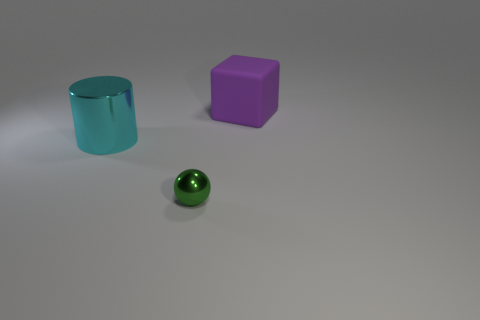What number of big things are both on the right side of the tiny metallic object and on the left side of the big cube?
Ensure brevity in your answer.  0. There is a object in front of the cyan cylinder; what is its material?
Give a very brief answer. Metal. The cylinder that is the same material as the tiny thing is what size?
Keep it short and to the point. Large. Is the size of the object behind the big cyan metallic object the same as the metal thing that is right of the large cyan object?
Your answer should be compact. No. What material is the cube that is the same size as the cyan cylinder?
Ensure brevity in your answer.  Rubber. There is a object that is in front of the purple cube and to the right of the large metal cylinder; what material is it made of?
Offer a terse response. Metal. Are any purple rubber objects visible?
Your answer should be very brief. Yes. Does the metallic cylinder have the same color as the tiny metallic sphere that is in front of the big cyan metallic cylinder?
Offer a very short reply. No. Is there any other thing that has the same shape as the tiny green metal object?
Provide a short and direct response. No. There is a object on the left side of the metallic thing to the right of the large object that is in front of the big rubber thing; what is its shape?
Provide a short and direct response. Cylinder. 